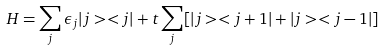<formula> <loc_0><loc_0><loc_500><loc_500>H = \sum _ { j } \epsilon _ { j } | j > < j | + t \sum _ { j } [ | j > < j + 1 | + | j > < j - 1 | ]</formula> 